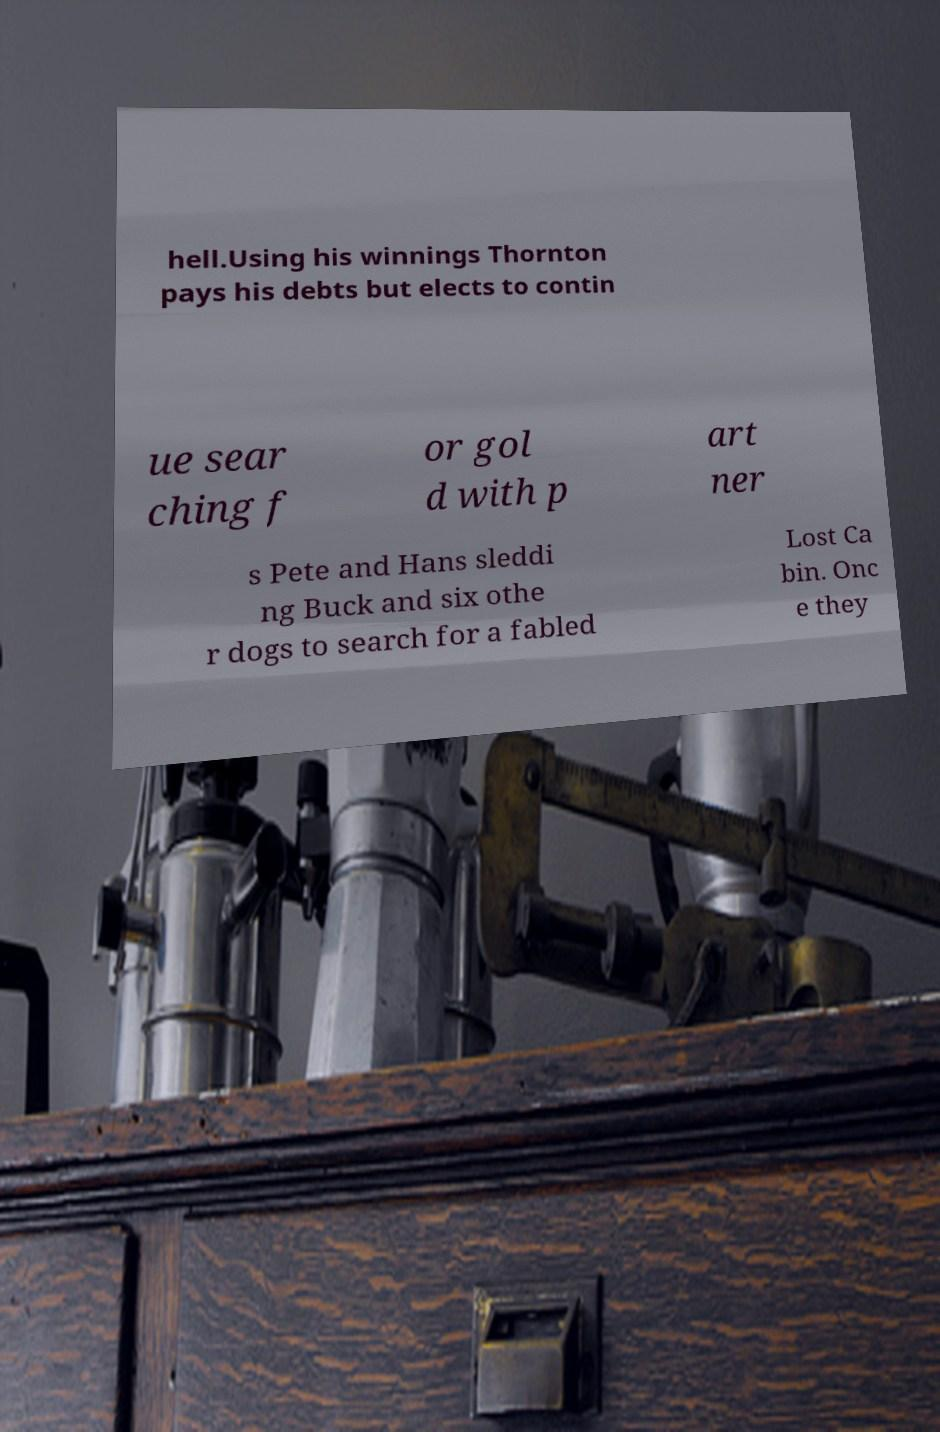What messages or text are displayed in this image? I need them in a readable, typed format. hell.Using his winnings Thornton pays his debts but elects to contin ue sear ching f or gol d with p art ner s Pete and Hans sleddi ng Buck and six othe r dogs to search for a fabled Lost Ca bin. Onc e they 